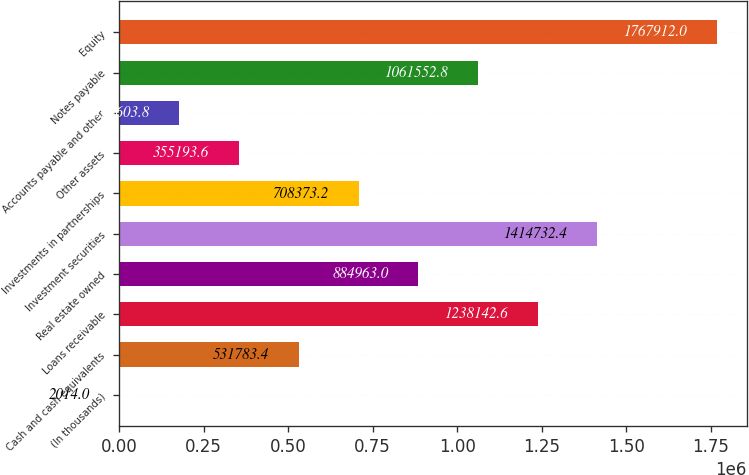Convert chart to OTSL. <chart><loc_0><loc_0><loc_500><loc_500><bar_chart><fcel>(In thousands)<fcel>Cash and cash equivalents<fcel>Loans receivable<fcel>Real estate owned<fcel>Investment securities<fcel>Investments in partnerships<fcel>Other assets<fcel>Accounts payable and other<fcel>Notes payable<fcel>Equity<nl><fcel>2014<fcel>531783<fcel>1.23814e+06<fcel>884963<fcel>1.41473e+06<fcel>708373<fcel>355194<fcel>178604<fcel>1.06155e+06<fcel>1.76791e+06<nl></chart> 